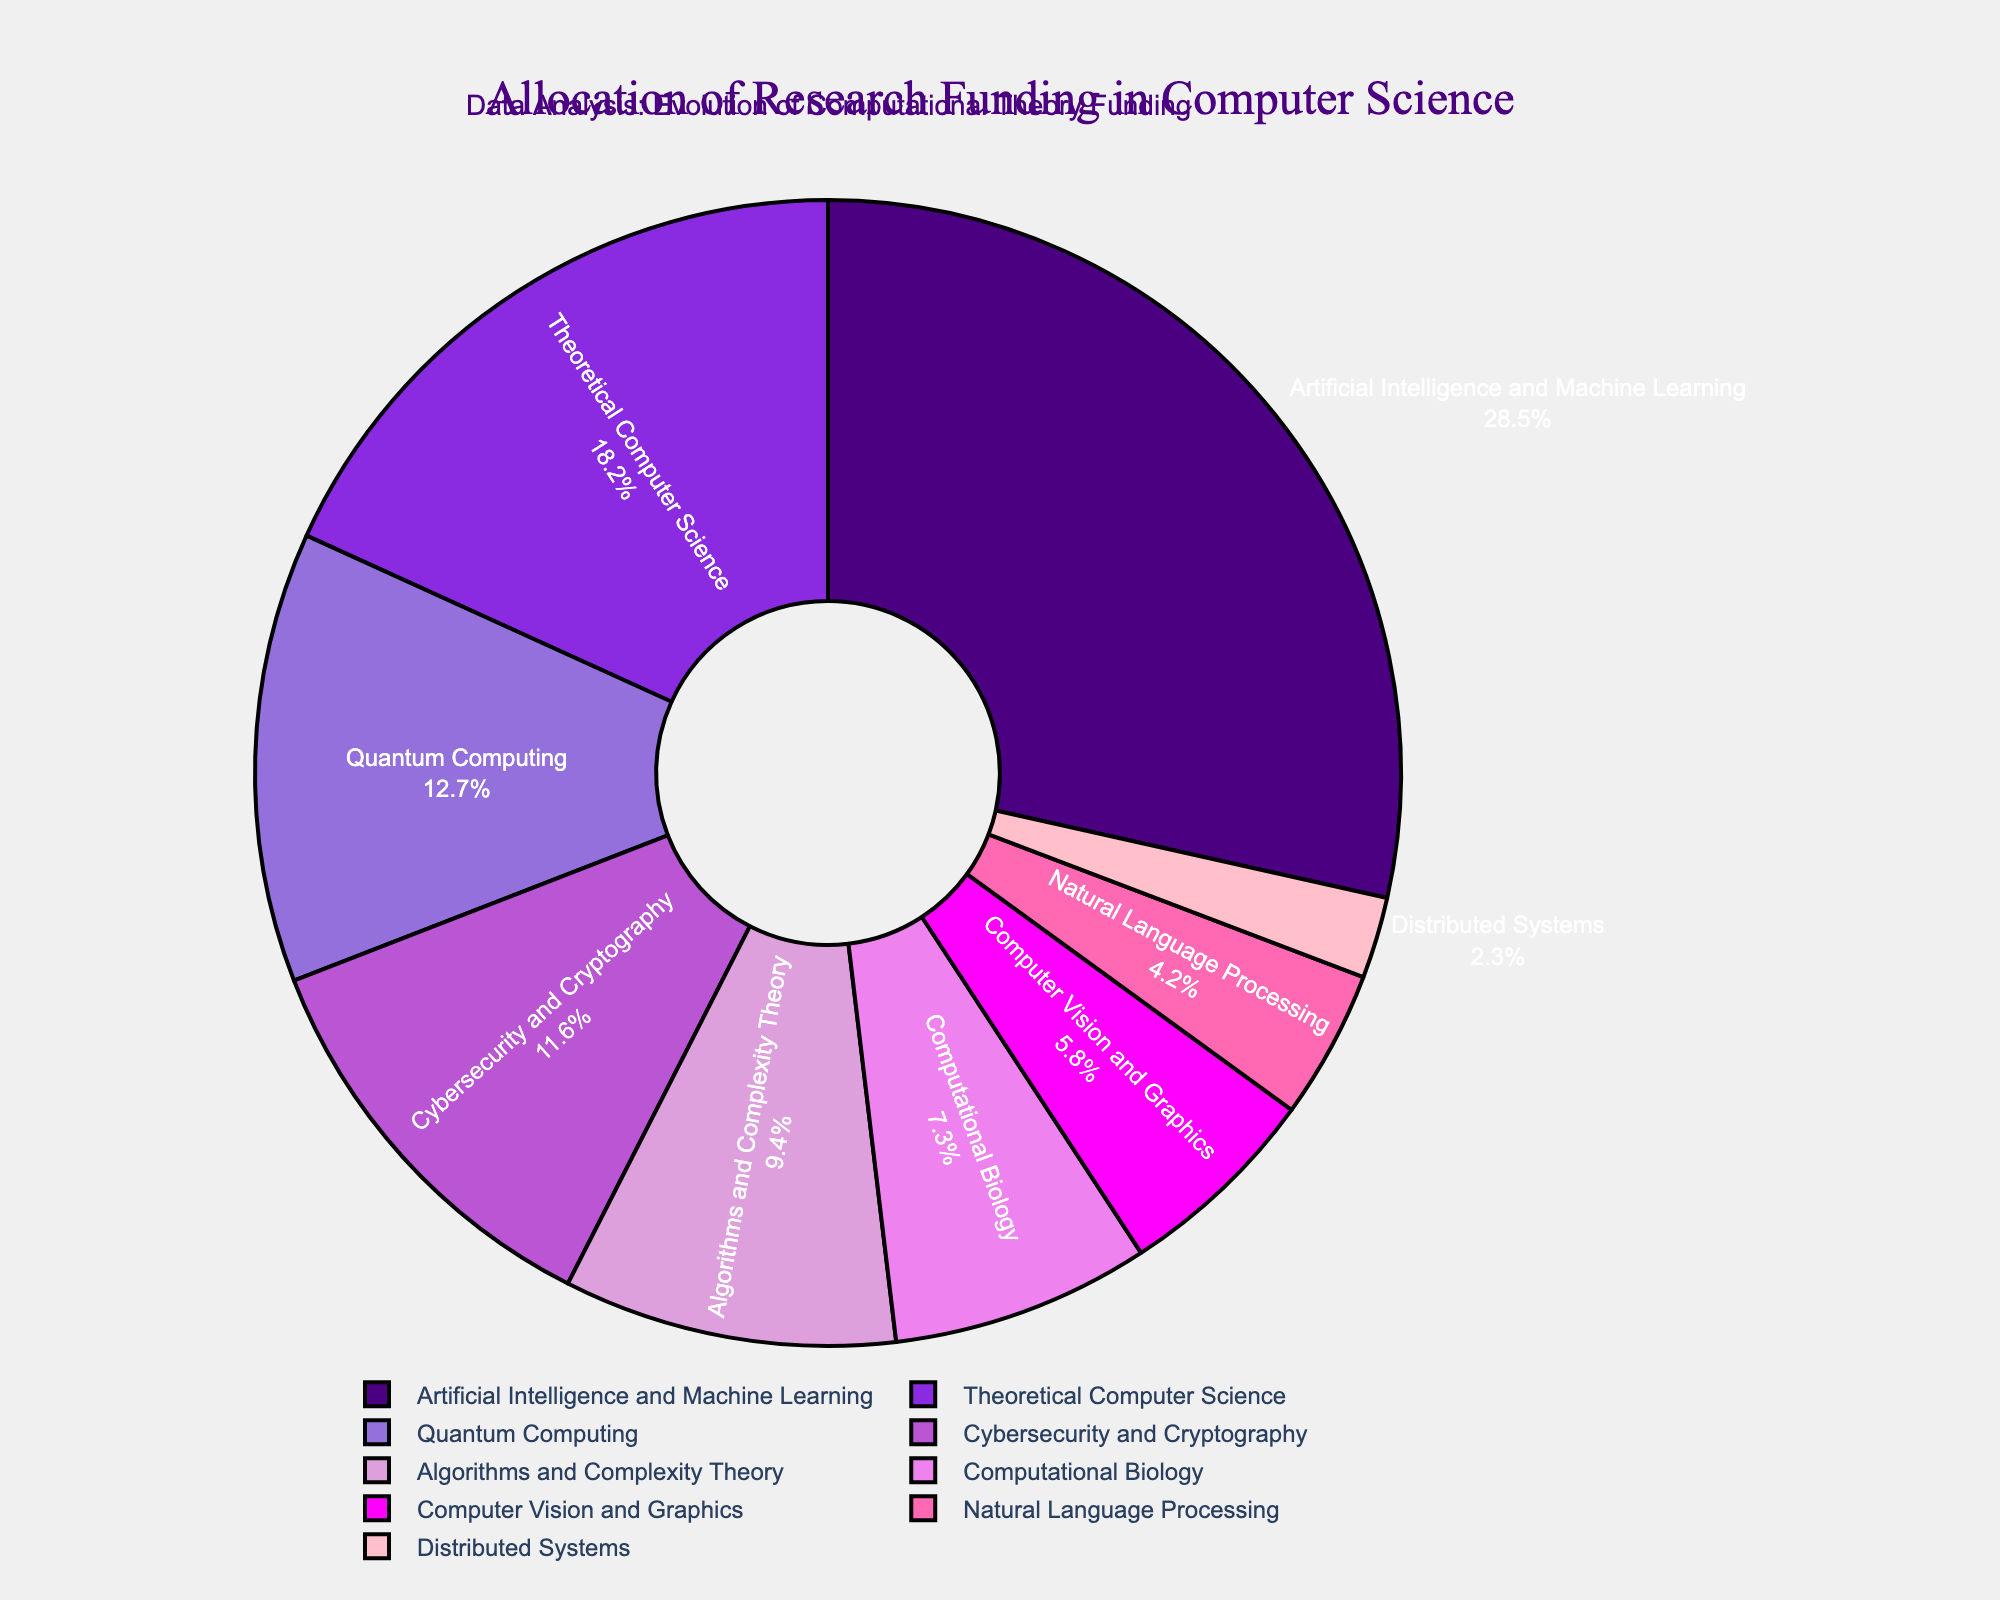What is the largest allocated subfield in terms of research funding? By examining the pie chart, the segment size for "Artificial Intelligence and Machine Learning" appears to be the largest portion of the pie.
Answer: Artificial Intelligence and Machine Learning Which subfield receives more funding: Quantum Computing or Cybersecurity and Cryptography? Comparing the slices, "Quantum Computing" has a slice labeled with a higher percentage (12.7%) than "Cybersecurity and Cryptography" (11.6%).
Answer: Quantum Computing What is the combined funding percentage for Algorithms and Complexity Theory, Computational Biology, and Computer Vision and Graphics? Adding the percentages of the three subfields: 9.4% (Algorithms and Complexity Theory) + 7.3% (Computational Biology) + 5.8% (Computer Vision and Graphics) = 22.5%.
Answer: 22.5% How much more funding does Theoretical Computer Science receive compared to Natural Language Processing? Subtracting the percentage of Natural Language Processing (4.2%) from Theoretical Computer Science (18.2%): 18.2% - 4.2% = 14.0%.
Answer: 14.0% Which subfield has the smallest allocation of research funding? The smallest slice in the pie chart is labeled "Distributed Systems" with 2.3%.
Answer: Distributed Systems Which two subfields have funding percentages closest to each other? By examining the slices, "Cybersecurity and Cryptography" (11.6%) and "Quantum Computing" (12.7%) have funding percentages that are very close, with a difference of only 1.1%.
Answer: Cybersecurity and Cryptography, Quantum Computing What is the difference in funding allocation between Theoretical Computer Science and Algorithms and Complexity Theory? Subtracting the percentage of Algorithms and Complexity Theory (9.4%) from Theoretical Computer Science (18.2%): 18.2% - 9.4% = 8.8%.
Answer: 8.8% What is the average funding percentage for the subfields that receive more than 10% funding? The subfields with more than 10% funding are: Artificial Intelligence and Machine Learning (28.5%), Theoretical Computer Science (18.2%), and Quantum Computing (12.7%), Cybersecurity and Cryptography (11.6%). Adding these percentages: 28.5% + 18.2% + 12.7% + 11.6% = 71.0%. The average is 71.0% / 4 = 17.75%.
Answer: 17.75% 